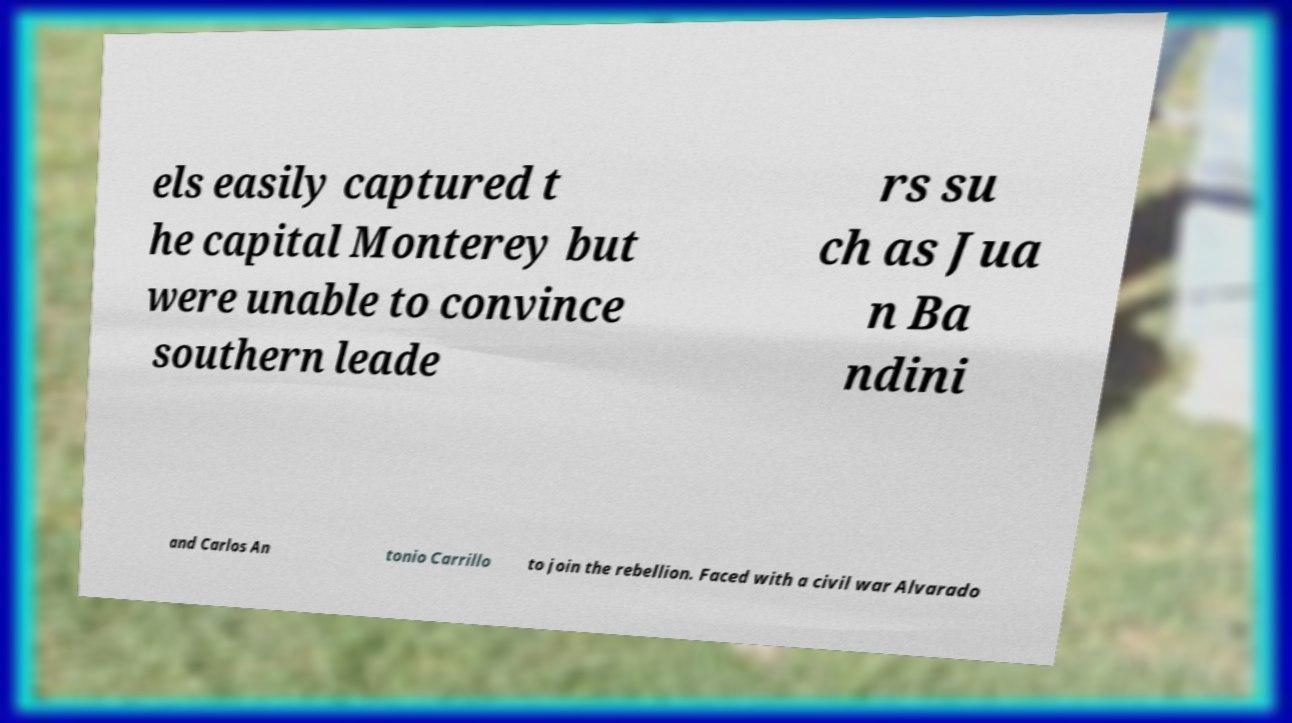Could you extract and type out the text from this image? els easily captured t he capital Monterey but were unable to convince southern leade rs su ch as Jua n Ba ndini and Carlos An tonio Carrillo to join the rebellion. Faced with a civil war Alvarado 